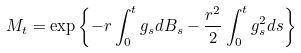<formula> <loc_0><loc_0><loc_500><loc_500>M _ { t } = \exp \left \{ - r \int _ { 0 } ^ { t } g _ { s } d B _ { s } - \frac { r ^ { 2 } } { 2 } \int _ { 0 } ^ { t } g _ { s } ^ { 2 } d s \right \}</formula> 